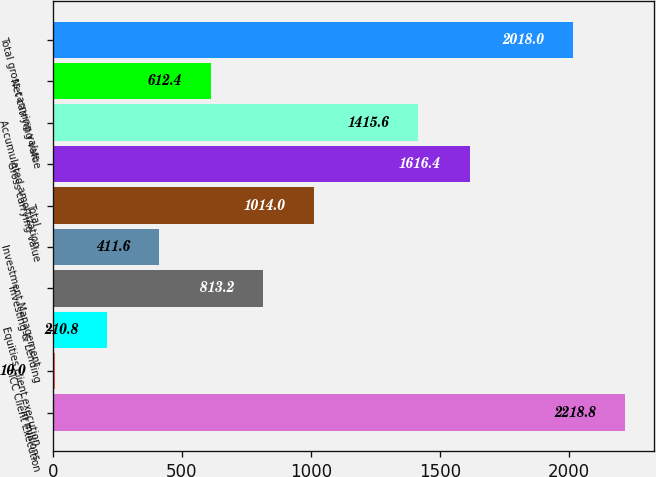Convert chart. <chart><loc_0><loc_0><loc_500><loc_500><bar_chart><fcel>in millions<fcel>FICC Client Execution<fcel>Equities client execution<fcel>Investing & Lending<fcel>Investment Management<fcel>Total<fcel>Gross carrying value<fcel>Accumulated amortization<fcel>Net carrying value<fcel>Total gross carrying value<nl><fcel>2218.8<fcel>10<fcel>210.8<fcel>813.2<fcel>411.6<fcel>1014<fcel>1616.4<fcel>1415.6<fcel>612.4<fcel>2018<nl></chart> 